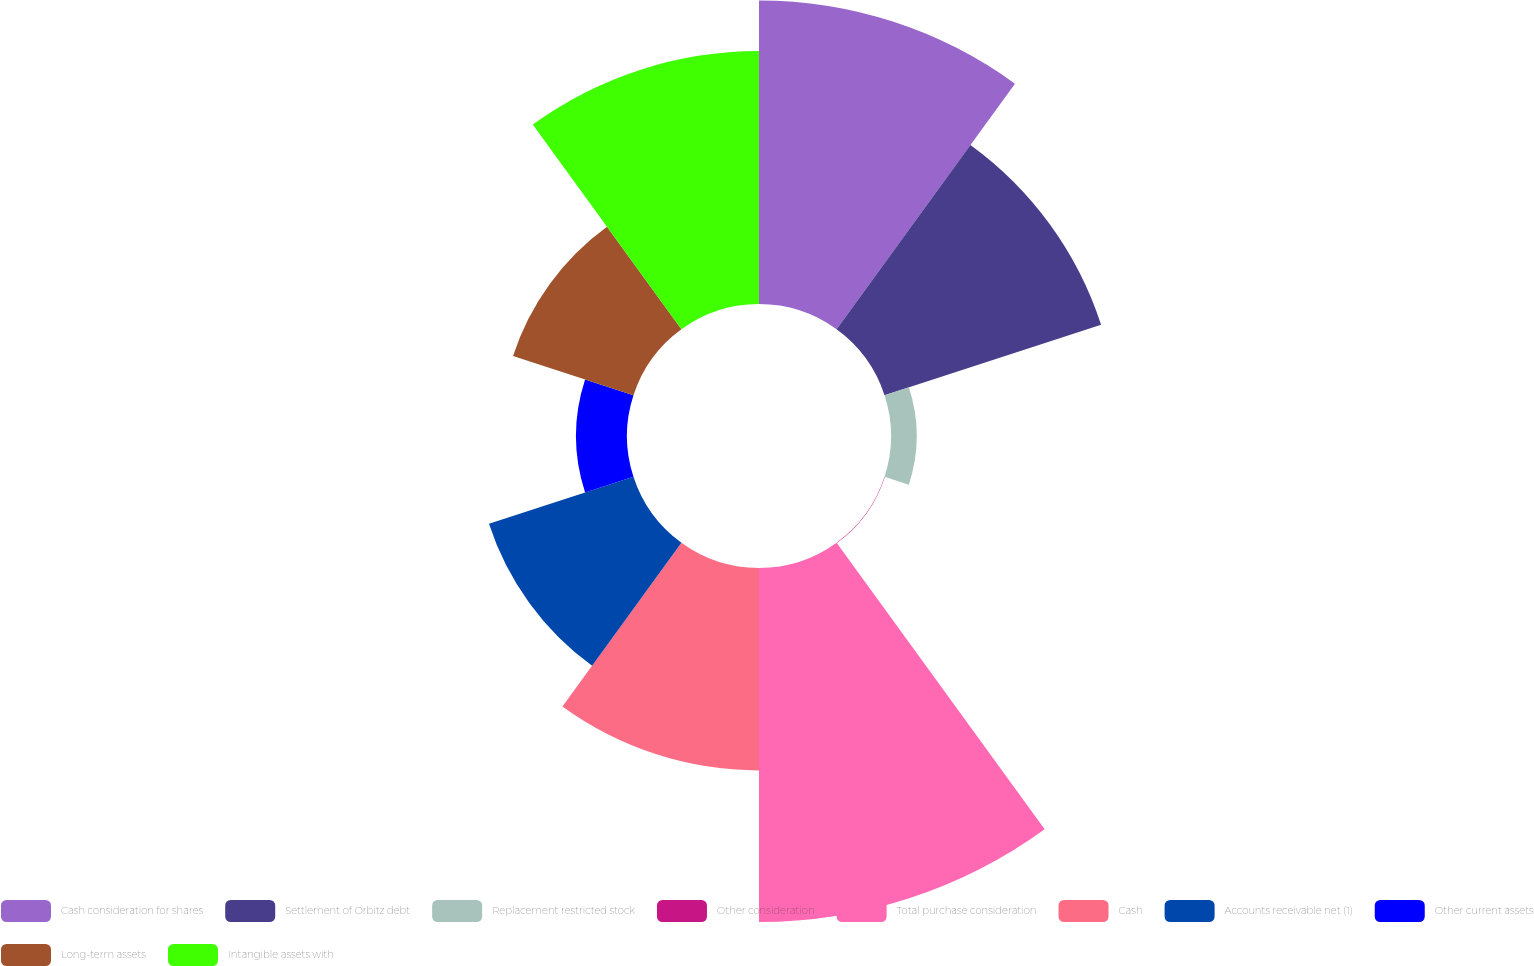Convert chart. <chart><loc_0><loc_0><loc_500><loc_500><pie_chart><fcel>Cash consideration for shares<fcel>Settlement of Orbitz debt<fcel>Replacement restricted stock<fcel>Other consideration<fcel>Total purchase consideration<fcel>Cash<fcel>Accounts receivable net (1)<fcel>Other current assets<fcel>Long-term assets<fcel>Intangible assets with<nl><fcel>17.9%<fcel>13.43%<fcel>1.51%<fcel>0.02%<fcel>20.88%<fcel>11.94%<fcel>8.96%<fcel>3.0%<fcel>7.47%<fcel>14.92%<nl></chart> 